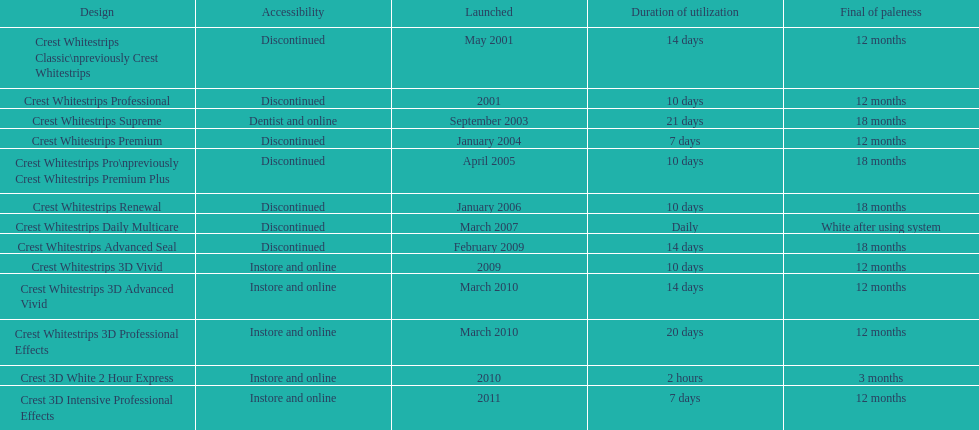Tell me the number of products that give you 12 months of whiteness. 7. 